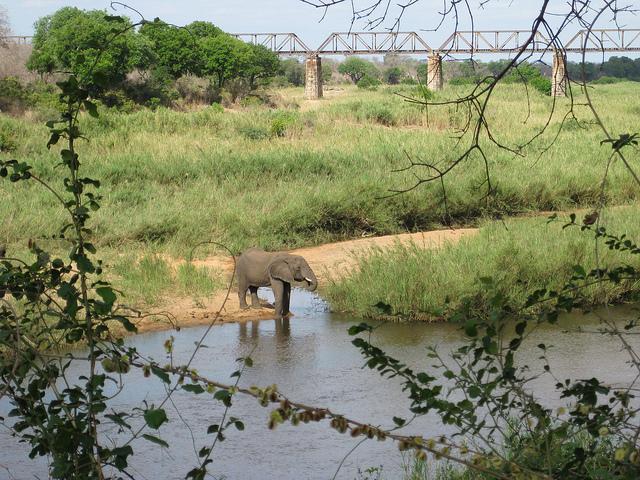How many elephants are viewed here?
Give a very brief answer. 1. How many elephants are there?
Give a very brief answer. 1. How many people are not playing with the wii?
Give a very brief answer. 0. 